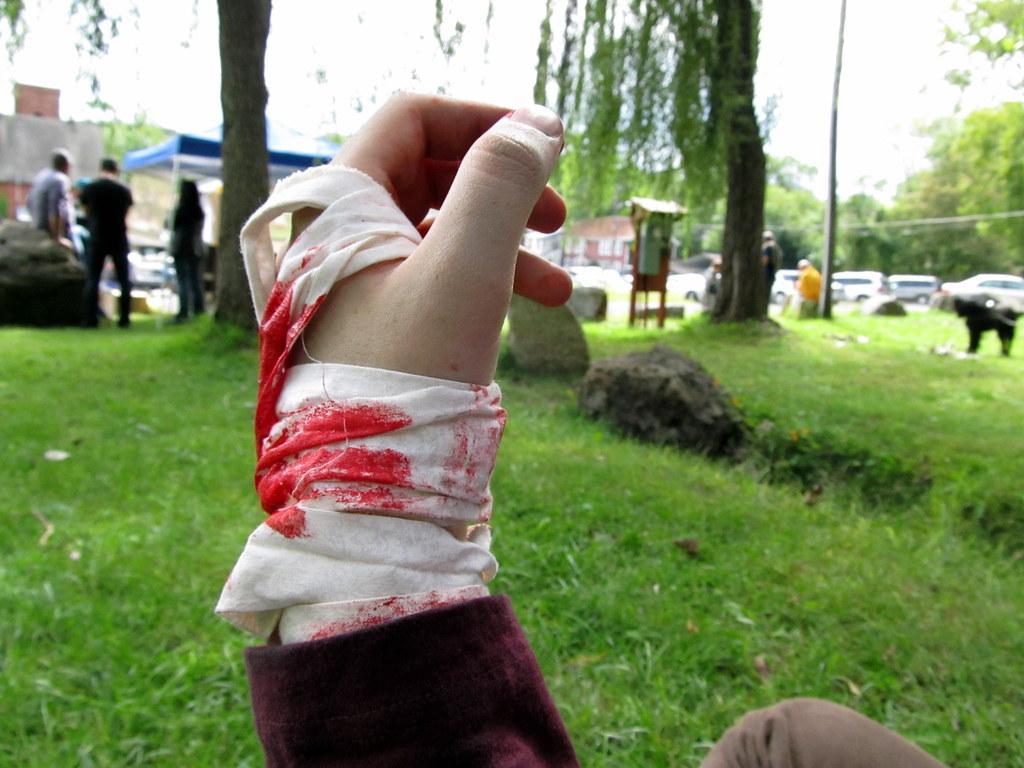Could you give a brief overview of what you see in this image? In this picture we can see grass, few vehicles and few people, in the background we can find few trees, buildings and a dog, and also we can see rocks. 